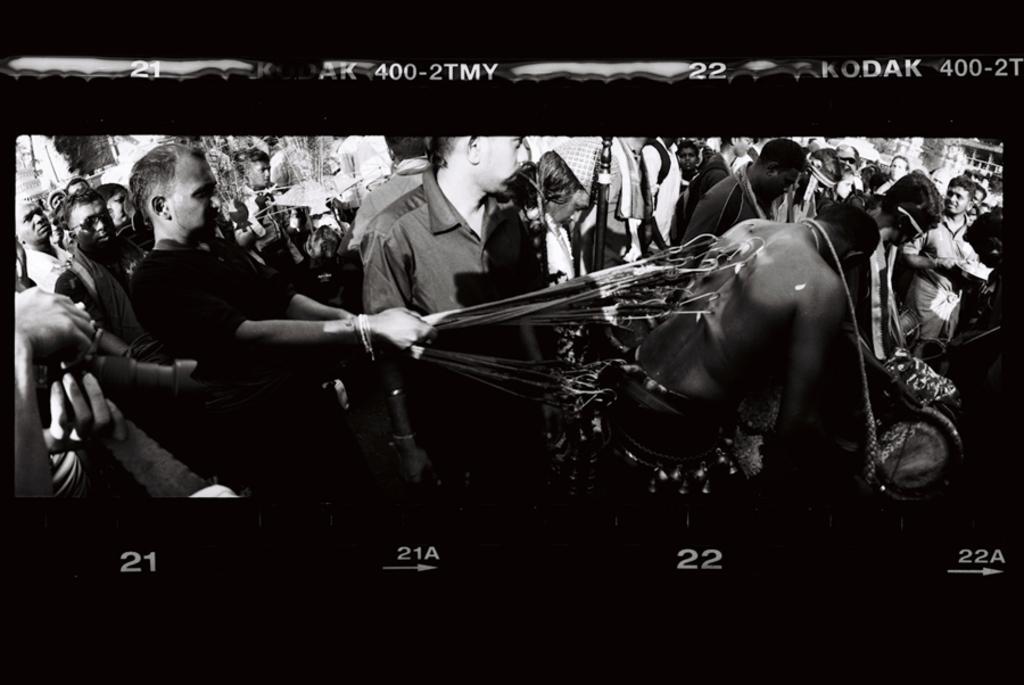Can you describe this image briefly? In the image we can see there are people standing and they are beating few people with sharp iron tool. The image is in black and white colour. 